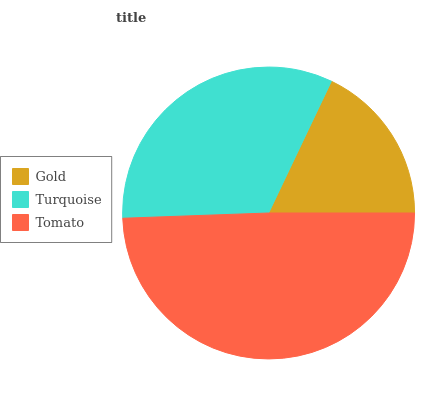Is Gold the minimum?
Answer yes or no. Yes. Is Tomato the maximum?
Answer yes or no. Yes. Is Turquoise the minimum?
Answer yes or no. No. Is Turquoise the maximum?
Answer yes or no. No. Is Turquoise greater than Gold?
Answer yes or no. Yes. Is Gold less than Turquoise?
Answer yes or no. Yes. Is Gold greater than Turquoise?
Answer yes or no. No. Is Turquoise less than Gold?
Answer yes or no. No. Is Turquoise the high median?
Answer yes or no. Yes. Is Turquoise the low median?
Answer yes or no. Yes. Is Gold the high median?
Answer yes or no. No. Is Gold the low median?
Answer yes or no. No. 